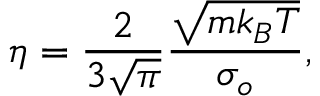<formula> <loc_0><loc_0><loc_500><loc_500>\eta = \frac { 2 } { 3 \sqrt { \pi } } \frac { \sqrt { m k _ { B } T } } { \sigma _ { o } } ,</formula> 